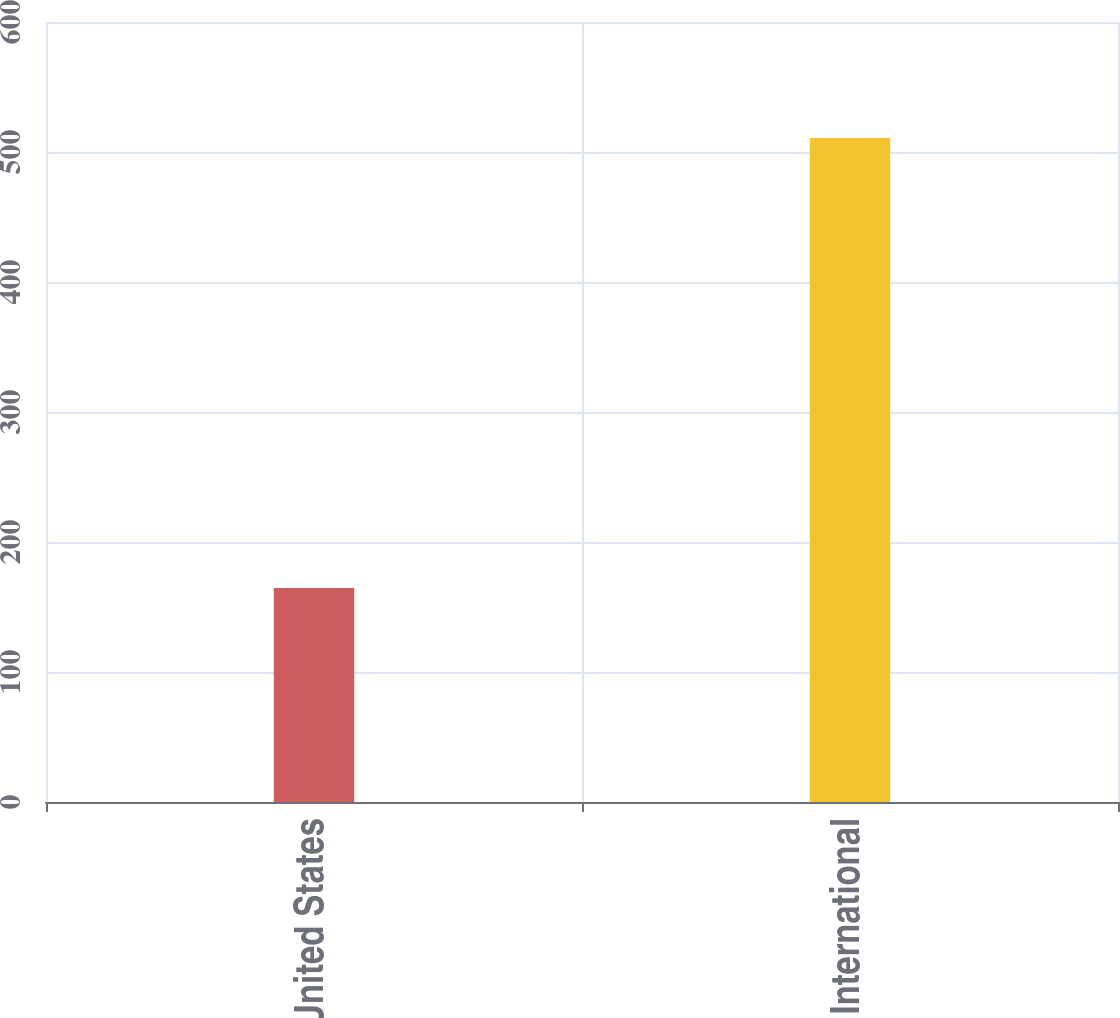<chart> <loc_0><loc_0><loc_500><loc_500><bar_chart><fcel>United States<fcel>International<nl><fcel>164.6<fcel>510.7<nl></chart> 